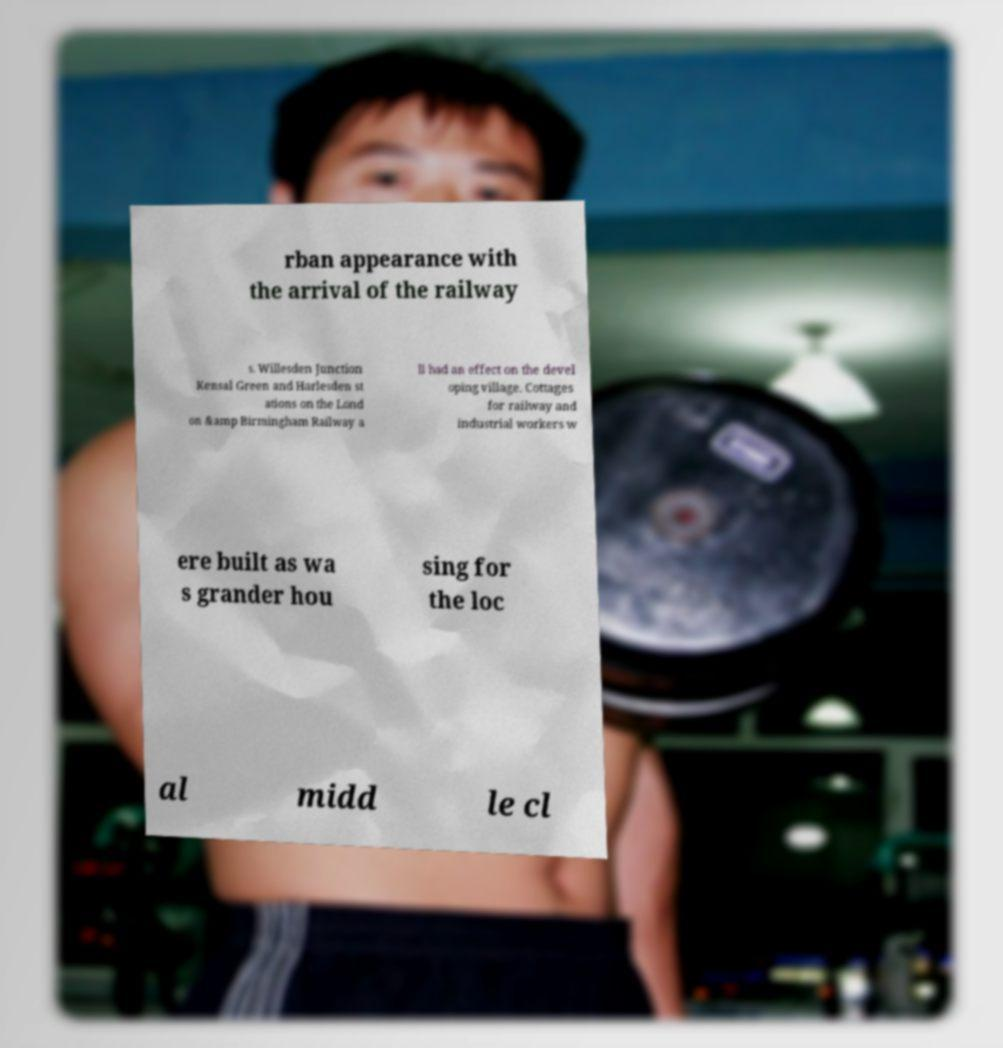Can you accurately transcribe the text from the provided image for me? rban appearance with the arrival of the railway s. Willesden Junction Kensal Green and Harlesden st ations on the Lond on &amp Birmingham Railway a ll had an effect on the devel oping village. Cottages for railway and industrial workers w ere built as wa s grander hou sing for the loc al midd le cl 